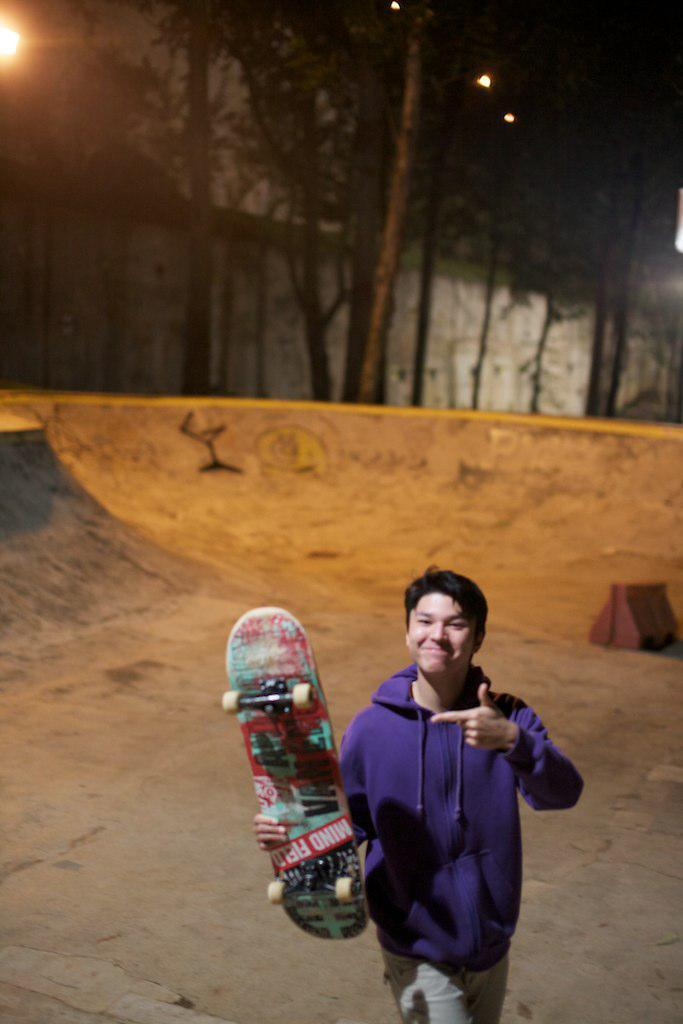What is the main subject of the image? There is a person in the center of the image. What is the person holding in the image? The person is holding a skateboard. What is the person doing in the image? The person is walking. What can be seen in the background of the image? There is a slope, houses, trees, and lights in the background of the image. What type of soap is being used by the person in the image? There is no soap present in the image; the person is holding a skateboard and walking. What kind of rod can be seen in the image? There is no rod present in the image; the main focus is on the person, their skateboard, and the background. 